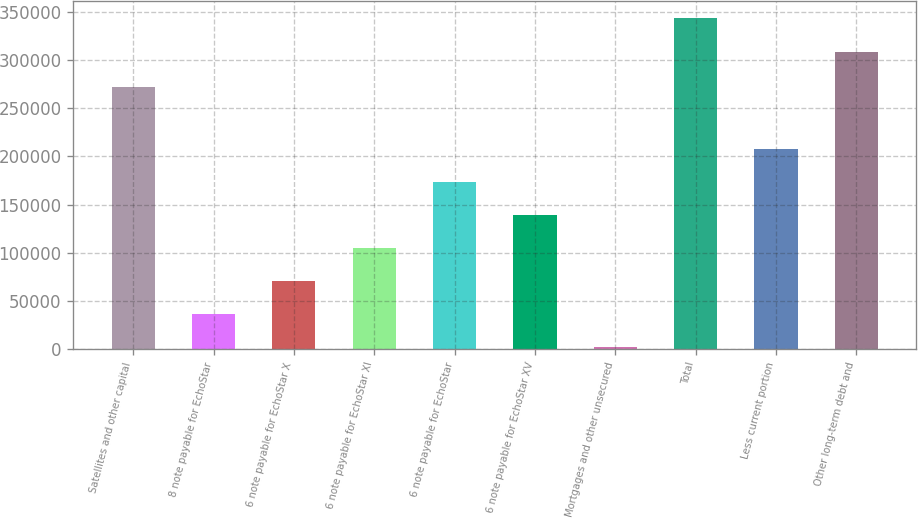<chart> <loc_0><loc_0><loc_500><loc_500><bar_chart><fcel>Satellites and other capital<fcel>8 note payable for EchoStar<fcel>6 note payable for EchoStar X<fcel>6 note payable for EchoStar XI<fcel>6 note payable for EchoStar<fcel>6 note payable for EchoStar XV<fcel>Mortgages and other unsecured<fcel>Total<fcel>Less current portion<fcel>Other long-term debt and<nl><fcel>271908<fcel>36384<fcel>70539<fcel>104694<fcel>173004<fcel>138849<fcel>2229<fcel>343779<fcel>207159<fcel>308134<nl></chart> 